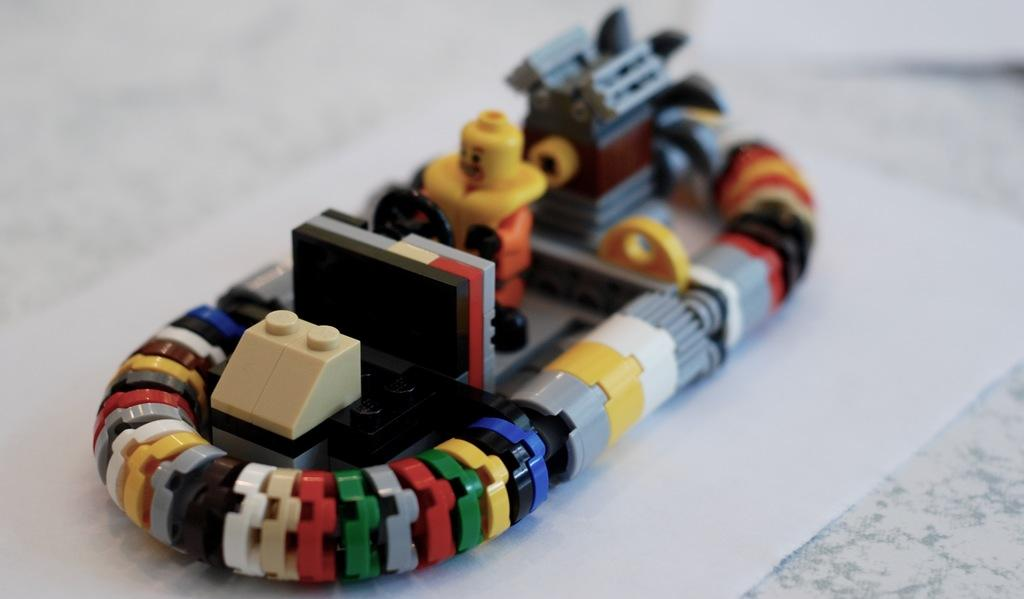What is the main subject of the picture? The main subject of the picture is a scale model of a boat. What other type of object is present in the image? There is a toy in the picture. What is the color of the surface on which the objects are placed? The objects are placed on a white surface. What type of voice can be heard coming from the toy in the image? There is no indication in the image that the toy has a voice or makes any sounds. 